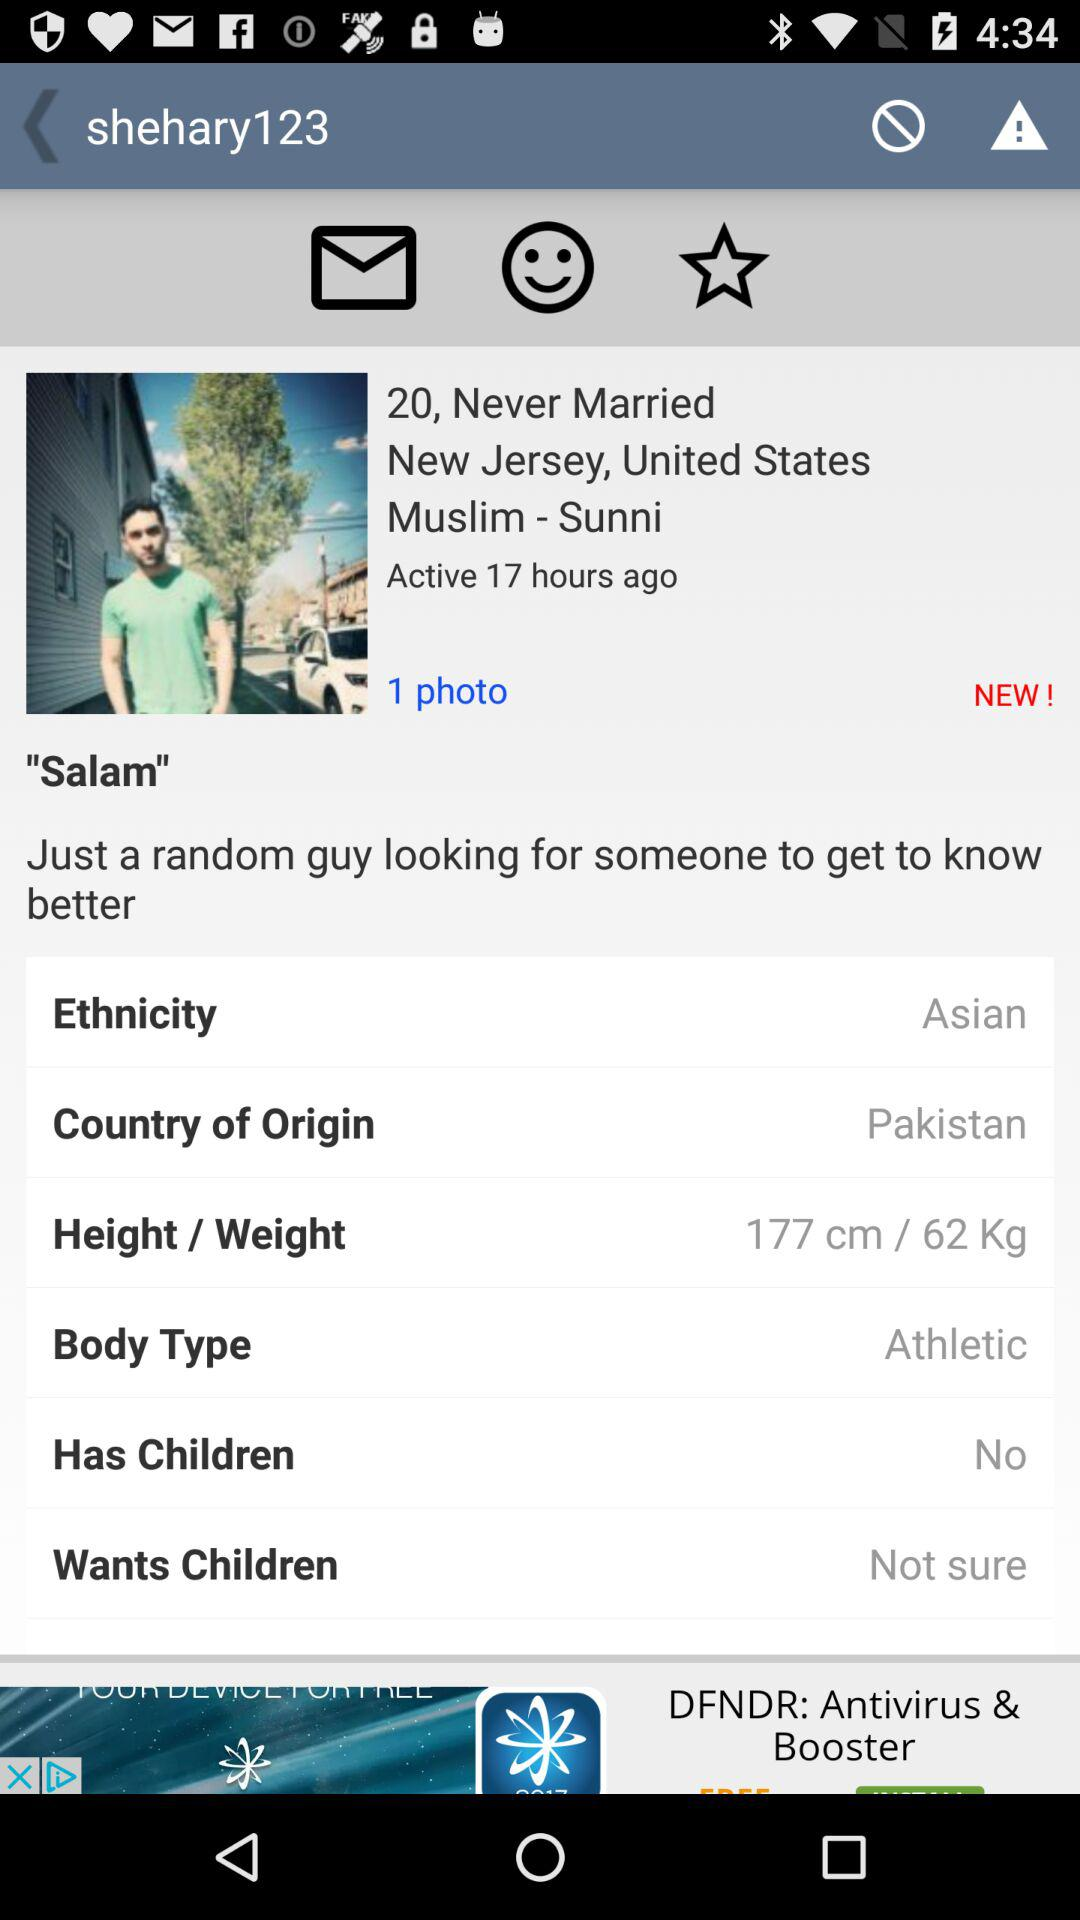How many hours ago was the user active? The user was last active 17 hours ago. 